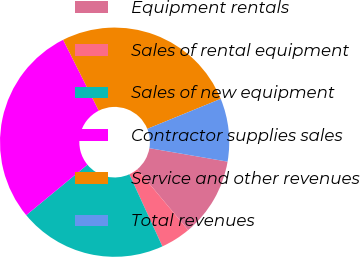Convert chart to OTSL. <chart><loc_0><loc_0><loc_500><loc_500><pie_chart><fcel>Equipment rentals<fcel>Sales of rental equipment<fcel>Sales of new equipment<fcel>Contractor supplies sales<fcel>Service and other revenues<fcel>Total revenues<nl><fcel>11.2%<fcel>4.25%<fcel>20.85%<fcel>28.57%<fcel>26.25%<fcel>8.88%<nl></chart> 